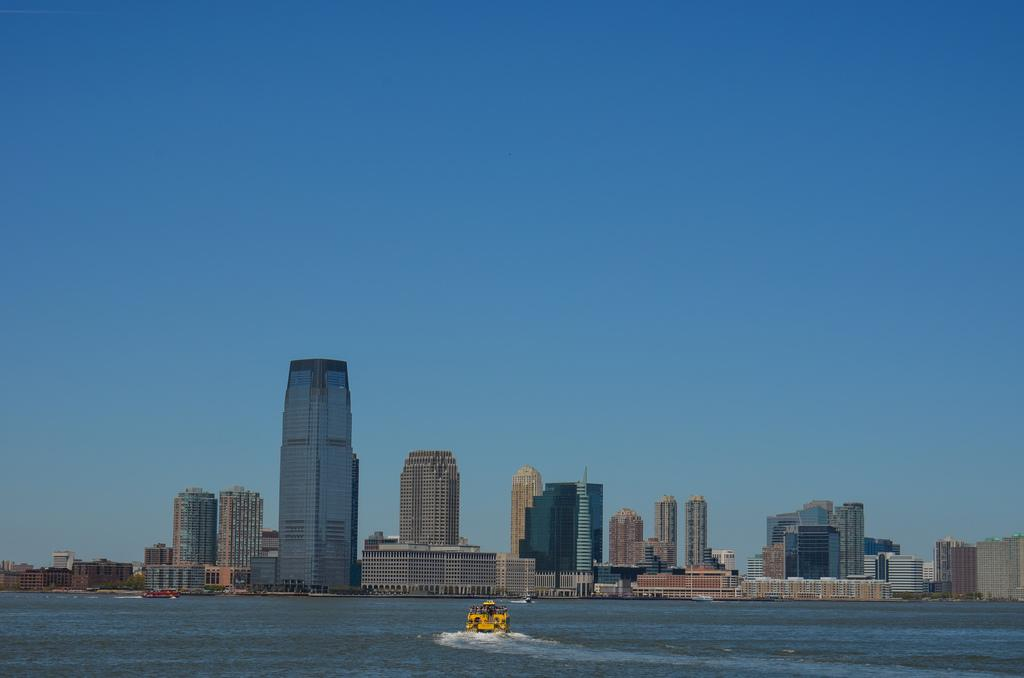What is the primary element in the image? There is water in the image. What type of vehicle is present in the water? There is a yellow boat in the image. What can be seen in the distance in the image? There are buildings in the background of the image. What is the condition of the sky in the image? The sky is clear and visible in the image. What type of instrument is being played by the person in the boat? There is no person or instrument present in the image; it only features a yellow boat in the water. 